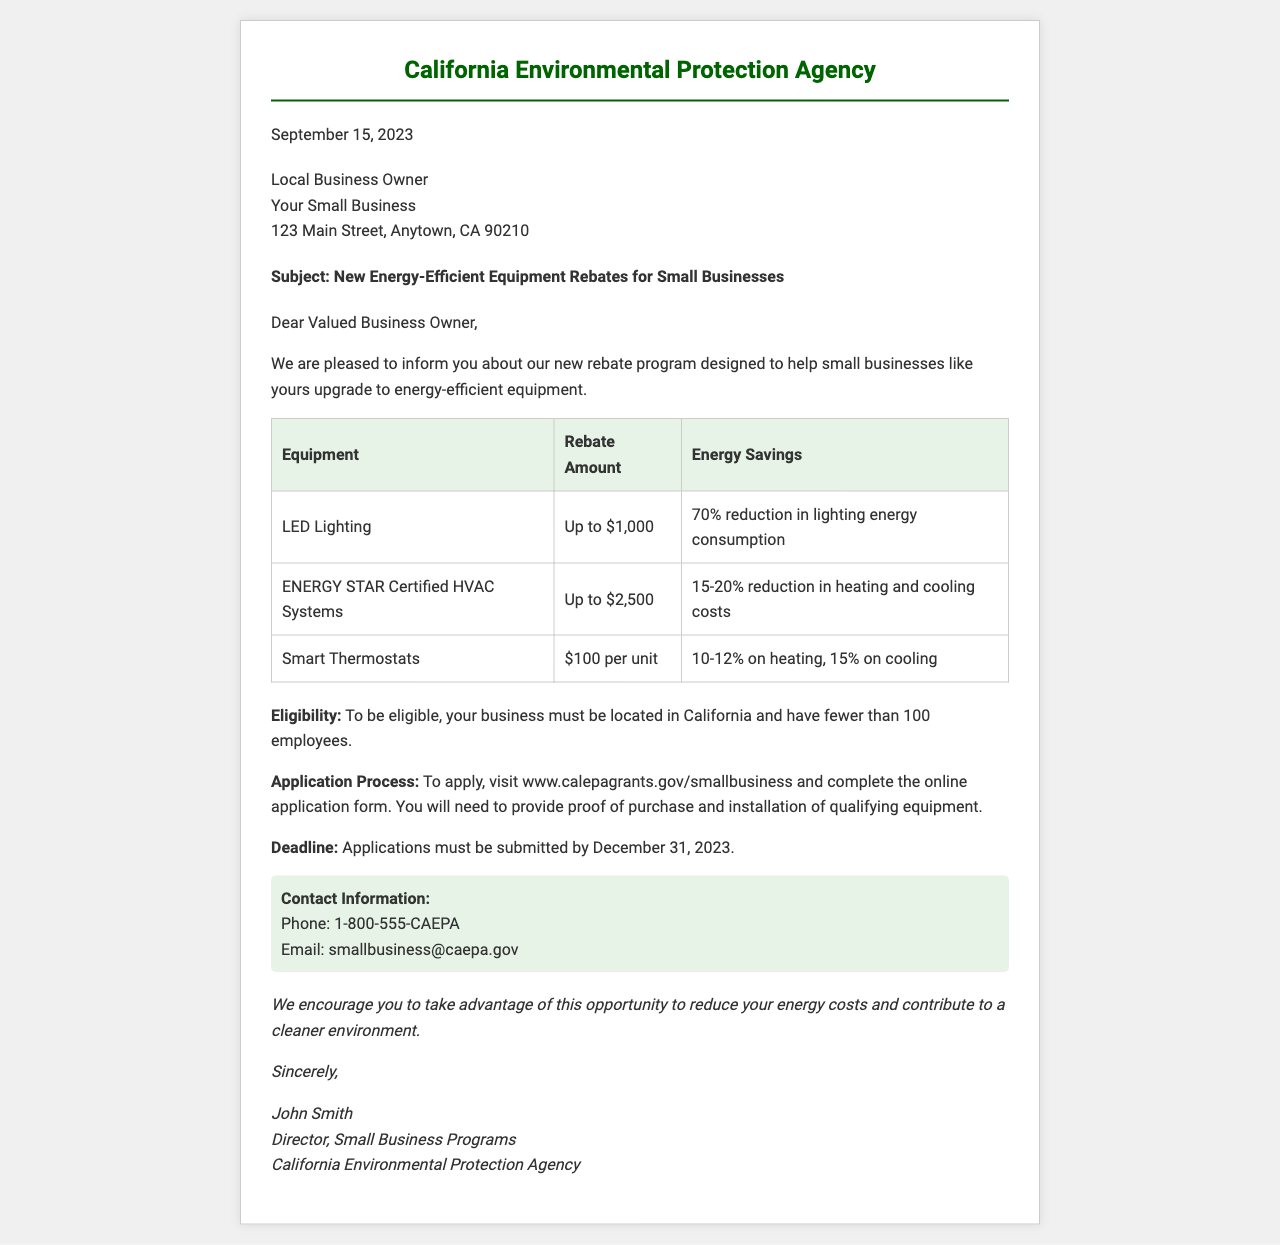what is the date of the fax? The date listed in the fax is September 15, 2023.
Answer: September 15, 2023 who is the sender of the fax? The fax is from the California Environmental Protection Agency.
Answer: California Environmental Protection Agency what is the maximum rebate amount for ENERGY STAR Certified HVAC Systems? The maximum rebate amount for ENERGY STAR Certified HVAC Systems is up to $2,500.
Answer: Up to $2,500 what is the eligibility criterion for the rebate program? The business must be located in California and have fewer than 100 employees.
Answer: Fewer than 100 employees when is the application deadline? The application deadline is December 31, 2023.
Answer: December 31, 2023 what is the energy savings for LED Lighting? The energy savings for LED Lighting is a 70% reduction in lighting energy consumption.
Answer: 70% reduction how can one apply for the rebate? To apply, visit www.calepagrants.gov/smallbusiness and complete the online application form.
Answer: Visit the website what contact method is provided for inquiries? The provided contact methods include phone and email.
Answer: Phone and email who is the recipient of the fax? The recipient is a Local Business Owner at Your Small Business.
Answer: Local Business Owner 